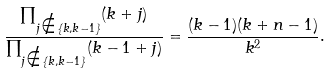Convert formula to latex. <formula><loc_0><loc_0><loc_500><loc_500>\frac { \prod _ { j \notin \{ k , k - 1 \} } ( k + j ) } { \prod _ { j \notin \{ k , k - 1 \} } ( k - 1 + j ) } = \frac { ( k - 1 ) ( k + n - 1 ) } { k ^ { 2 } } .</formula> 